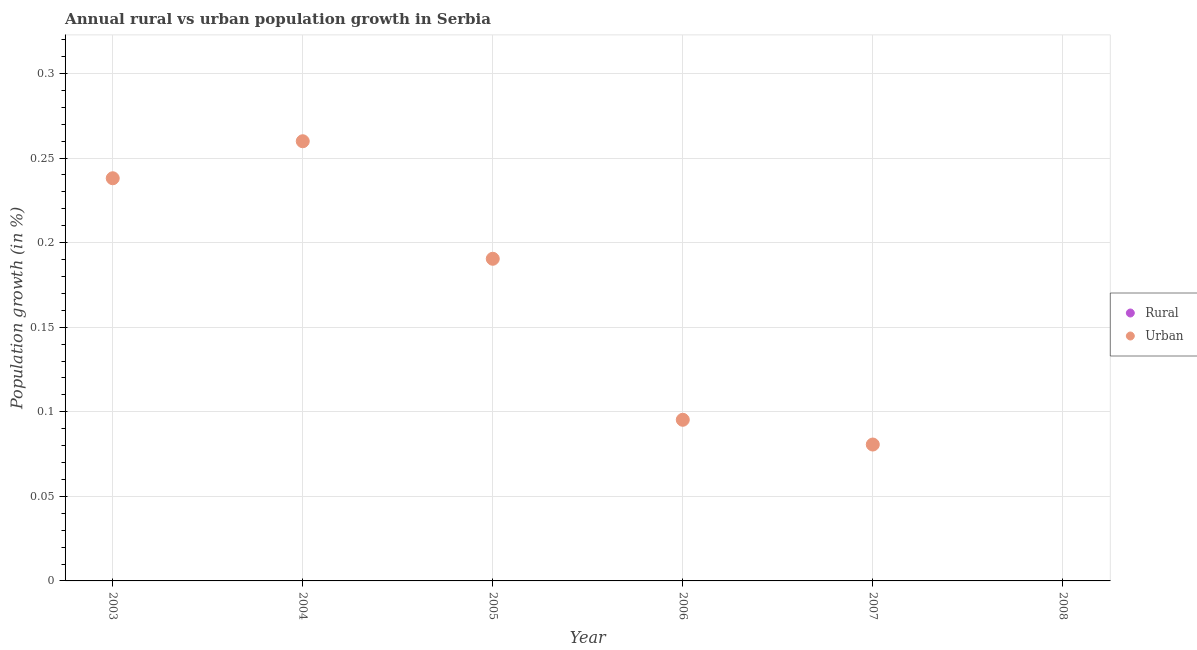How many different coloured dotlines are there?
Offer a terse response. 1. Across all years, what is the maximum urban population growth?
Your answer should be compact. 0.26. In which year was the urban population growth maximum?
Provide a short and direct response. 2004. What is the total rural population growth in the graph?
Your answer should be compact. 0. What is the difference between the urban population growth in 2003 and that in 2007?
Offer a terse response. 0.16. What is the difference between the urban population growth in 2007 and the rural population growth in 2005?
Offer a very short reply. 0.08. What is the ratio of the urban population growth in 2004 to that in 2007?
Keep it short and to the point. 3.22. Is the urban population growth in 2005 less than that in 2006?
Offer a terse response. No. What is the difference between the highest and the second highest urban population growth?
Give a very brief answer. 0.02. What is the difference between the highest and the lowest urban population growth?
Keep it short and to the point. 0.26. In how many years, is the urban population growth greater than the average urban population growth taken over all years?
Make the answer very short. 3. Is the sum of the urban population growth in 2006 and 2007 greater than the maximum rural population growth across all years?
Provide a succinct answer. Yes. How many dotlines are there?
Keep it short and to the point. 1. Are the values on the major ticks of Y-axis written in scientific E-notation?
Your response must be concise. No. Does the graph contain grids?
Your answer should be very brief. Yes. How are the legend labels stacked?
Make the answer very short. Vertical. What is the title of the graph?
Make the answer very short. Annual rural vs urban population growth in Serbia. Does "Commercial bank branches" appear as one of the legend labels in the graph?
Your answer should be very brief. No. What is the label or title of the Y-axis?
Provide a short and direct response. Population growth (in %). What is the Population growth (in %) of Urban  in 2003?
Give a very brief answer. 0.24. What is the Population growth (in %) in Rural in 2004?
Your response must be concise. 0. What is the Population growth (in %) of Urban  in 2004?
Offer a very short reply. 0.26. What is the Population growth (in %) of Rural in 2005?
Provide a short and direct response. 0. What is the Population growth (in %) of Urban  in 2005?
Offer a terse response. 0.19. What is the Population growth (in %) of Rural in 2006?
Provide a short and direct response. 0. What is the Population growth (in %) of Urban  in 2006?
Your response must be concise. 0.1. What is the Population growth (in %) of Rural in 2007?
Offer a very short reply. 0. What is the Population growth (in %) in Urban  in 2007?
Provide a succinct answer. 0.08. Across all years, what is the maximum Population growth (in %) in Urban ?
Your answer should be very brief. 0.26. What is the total Population growth (in %) of Rural in the graph?
Provide a short and direct response. 0. What is the total Population growth (in %) in Urban  in the graph?
Provide a short and direct response. 0.86. What is the difference between the Population growth (in %) of Urban  in 2003 and that in 2004?
Ensure brevity in your answer.  -0.02. What is the difference between the Population growth (in %) of Urban  in 2003 and that in 2005?
Keep it short and to the point. 0.05. What is the difference between the Population growth (in %) of Urban  in 2003 and that in 2006?
Make the answer very short. 0.14. What is the difference between the Population growth (in %) of Urban  in 2003 and that in 2007?
Your response must be concise. 0.16. What is the difference between the Population growth (in %) of Urban  in 2004 and that in 2005?
Provide a succinct answer. 0.07. What is the difference between the Population growth (in %) in Urban  in 2004 and that in 2006?
Make the answer very short. 0.16. What is the difference between the Population growth (in %) in Urban  in 2004 and that in 2007?
Your answer should be compact. 0.18. What is the difference between the Population growth (in %) of Urban  in 2005 and that in 2006?
Offer a terse response. 0.1. What is the difference between the Population growth (in %) of Urban  in 2005 and that in 2007?
Provide a succinct answer. 0.11. What is the difference between the Population growth (in %) of Urban  in 2006 and that in 2007?
Ensure brevity in your answer.  0.01. What is the average Population growth (in %) in Urban  per year?
Provide a succinct answer. 0.14. What is the ratio of the Population growth (in %) in Urban  in 2003 to that in 2004?
Your response must be concise. 0.92. What is the ratio of the Population growth (in %) in Urban  in 2003 to that in 2006?
Provide a short and direct response. 2.5. What is the ratio of the Population growth (in %) in Urban  in 2003 to that in 2007?
Offer a very short reply. 2.95. What is the ratio of the Population growth (in %) in Urban  in 2004 to that in 2005?
Make the answer very short. 1.36. What is the ratio of the Population growth (in %) of Urban  in 2004 to that in 2006?
Offer a very short reply. 2.73. What is the ratio of the Population growth (in %) in Urban  in 2004 to that in 2007?
Make the answer very short. 3.22. What is the ratio of the Population growth (in %) in Urban  in 2005 to that in 2006?
Provide a short and direct response. 2. What is the ratio of the Population growth (in %) of Urban  in 2005 to that in 2007?
Your answer should be compact. 2.36. What is the ratio of the Population growth (in %) in Urban  in 2006 to that in 2007?
Provide a succinct answer. 1.18. What is the difference between the highest and the second highest Population growth (in %) of Urban ?
Your response must be concise. 0.02. What is the difference between the highest and the lowest Population growth (in %) in Urban ?
Provide a short and direct response. 0.26. 